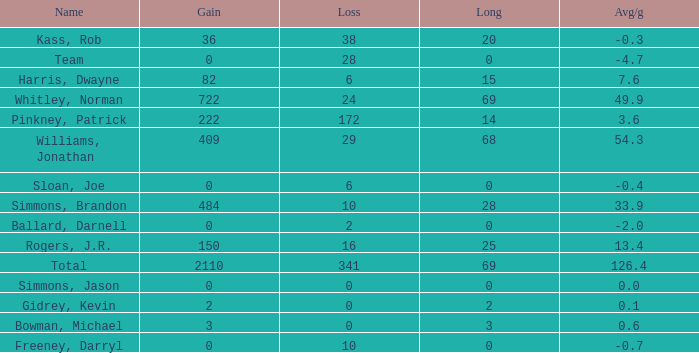What is the lowest Loss, when Long is less than 0? None. 